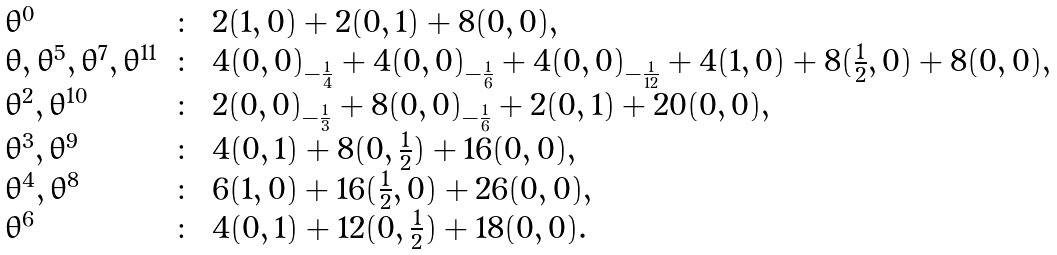Convert formula to latex. <formula><loc_0><loc_0><loc_500><loc_500>\begin{array} { l c l } \theta ^ { 0 } & \colon & 2 ( 1 , 0 ) + 2 ( 0 , 1 ) + 8 ( 0 , 0 ) , \\ \theta , \theta ^ { 5 } , \theta ^ { 7 } , \theta ^ { 1 1 } & \colon & 4 ( 0 , 0 ) _ { - \frac { 1 } { 4 } } + 4 ( 0 , 0 ) _ { - \frac { 1 } { 6 } } + 4 ( 0 , 0 ) _ { - \frac { 1 } { 1 2 } } + 4 ( 1 , 0 ) + 8 ( \frac { 1 } { 2 } , 0 ) + 8 ( 0 , 0 ) , \\ \theta ^ { 2 } , \theta ^ { 1 0 } & \colon & 2 ( 0 , 0 ) _ { - \frac { 1 } { 3 } } + 8 ( 0 , 0 ) _ { - \frac { 1 } { 6 } } + 2 ( 0 , 1 ) + 2 0 ( 0 , 0 ) , \\ \theta ^ { 3 } , \theta ^ { 9 } & \colon & 4 ( 0 , 1 ) + 8 ( 0 , \frac { 1 } { 2 } ) + 1 6 ( 0 , 0 ) , \\ \theta ^ { 4 } , \theta ^ { 8 } & \colon & 6 ( 1 , 0 ) + 1 6 ( \frac { 1 } { 2 } , 0 ) + 2 6 ( 0 , 0 ) , \\ \theta ^ { 6 } & \colon & 4 ( 0 , 1 ) + 1 2 ( 0 , \frac { 1 } { 2 } ) + 1 8 ( 0 , 0 ) . \end{array}</formula> 